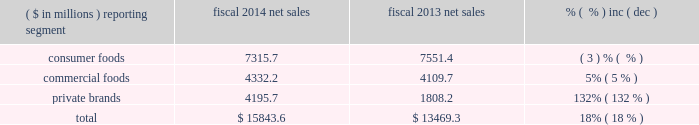Equity method investment earnings we include our share of the earnings of certain affiliates based on our economic ownership interest in the affiliates .
Significant affiliates include the ardent mills joint venture and affiliates that produce and market potato products for retail and foodservice customers .
Our share of earnings from our equity method investments was $ 122.1 million ( $ 119.1 million in the commercial foods segment and $ 3.0 million in the consumer foods segment ) and $ 32.5 million ( $ 29.7 million in the commercial foods segment and $ 2.8 million in the consumer foods segment ) in fiscal 2015 and 2014 , respectively .
The increase in fiscal 2015 compared to fiscal 2014 reflects the earnings from the ardent mills joint venture as well as higher profits for an international potato joint venture .
The earnings from the ardent mills joint venture reflect results for 11 months of operations , as we recognize earnings on a one-month lag , due to differences in fiscal year periods .
In fiscal 2014 , earnings also reflected a $ 3.4 million charge reflecting the year-end write-off of actuarial losses in excess of 10% ( 10 % ) of the pension liability for an international potato venture .
Results of discontinued operations our discontinued operations generated after-tax income of $ 366.6 million and $ 141.4 million in fiscal 2015 and 2014 , respectively .
The results of discontinued operations for fiscal 2015 include a pre-tax gain of $ 625.6 million ( $ 379.6 million after-tax ) recognized on the formation of the ardent mills joint venture .
The results for fiscal 2014 reflect a pre-tax gain of $ 90.0 million ( $ 55.7 million after-tax ) related to the disposition of three flour milling facilities as part of the ardent mills formation .
In fiscal 2014 , we also completed the sale of a small snack business , medallion foods , for $ 32.0 million in cash .
We recognized an after-tax loss of $ 3.5 million on the sale of this business in fiscal 2014 .
In fiscal 2014 , we recognized an impairment charge related to allocated amounts of goodwill and intangible assets , totaling $ 15.2 million after-tax , in anticipation of this divestiture .
We also completed the sale of the assets of the lightlife ae business for $ 54.7 million in cash .
We recognized an after-tax gain of $ 19.8 million on the sale of this business in fiscal 2014 .
Earnings ( loss ) per share diluted loss per share in fiscal 2015 was $ 0.60 , including a loss of $ 1.46 per diluted share from continuing operations and earnings of $ 0.86 per diluted share from discontinued operations .
Diluted earnings per share in fiscal 2014 were $ 0.70 , including $ 0.37 per diluted share from continuing operations and $ 0.33 per diluted share from discontinued operations .
See 201citems impacting comparability 201d above as several significant items affected the comparability of year-over-year results of operations .
Fiscal 2014 compared to fiscal 2013 net sales ( $ in millions ) reporting segment fiscal 2014 net sales fiscal 2013 net sales .
Overall , our net sales increased $ 2.37 billion to $ 15.84 billion in fiscal 2014 compared to fiscal 2013 , primarily related to the acquisition of ralcorp .
Consumer foods net sales for fiscal 2014 were $ 7.32 billion , a decrease of $ 235.7 million , or 3% ( 3 % ) , compared to fiscal 2013 .
Results reflected a 3% ( 3 % ) decrease in volume performance and a 1% ( 1 % ) decrease due to the impact of foreign exchange rates , partially offset by a 1% ( 1 % ) increase in price/mix .
Volume performance from our base businesses for fiscal 2014 was impacted negatively by competitor promotional activity .
Significant slotting and promotion investments related to new product launches , particularly in the first quarter , also weighed heavily on net sales in fiscal 2014 .
In addition , certain shipments planned for the fourth quarter of fiscal 2014 were shifted to the first quarter of fiscal 2015 as a result of change in timing of retailer promotions and this negatively impacted volume performance. .
What percent of net sales in fiscal 2014 where due to private brands? 
Computations: (4195.7 / 15843.6)
Answer: 0.26482. 